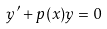Convert formula to latex. <formula><loc_0><loc_0><loc_500><loc_500>y ^ { \prime } + p ( x ) y = 0</formula> 